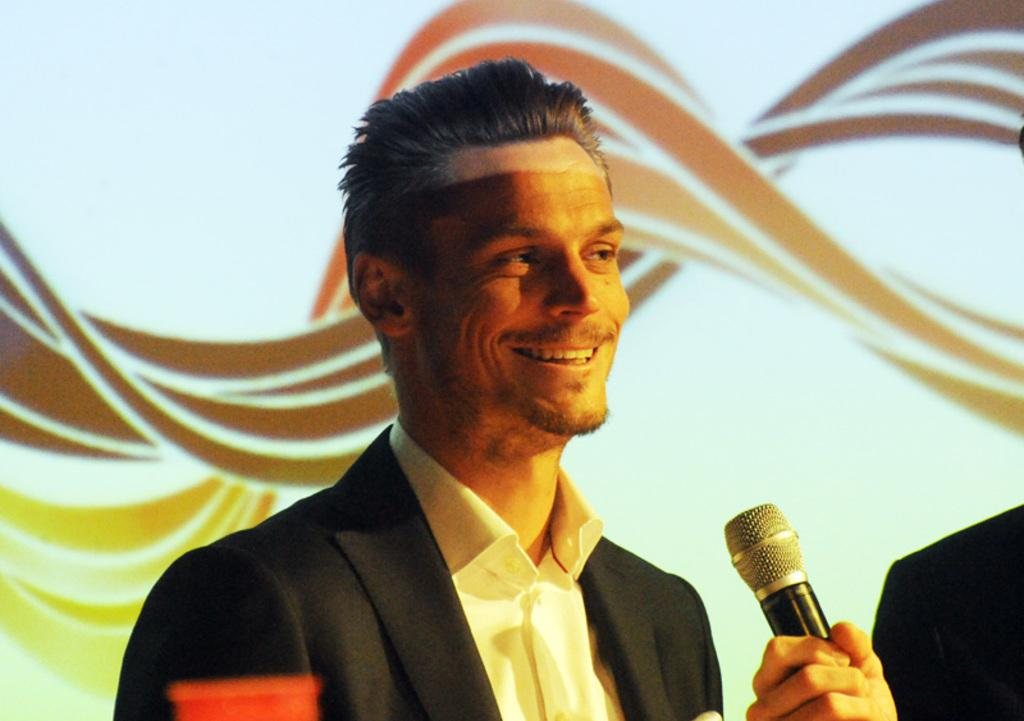What is the expression on the face of the man in the image? The man in the image is smiling. How many men are present in the image? There are two men in the image. What is the second man holding in his hand? The second man is holding a microphone in his hand. What type of apparel is the star wearing in the image? There is no star present in the image, so it is not possible to answer that question. 